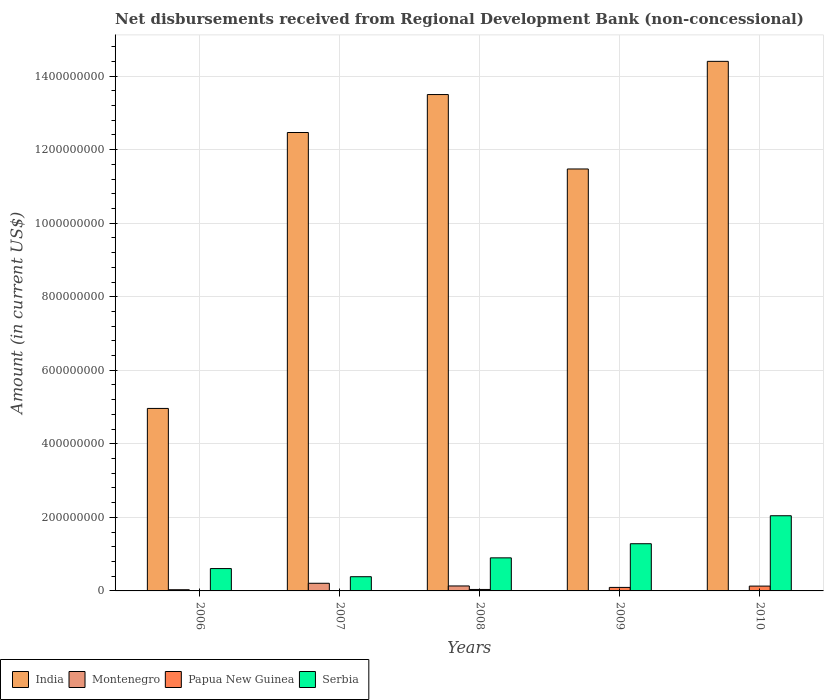How many different coloured bars are there?
Offer a terse response. 4. How many groups of bars are there?
Make the answer very short. 5. Are the number of bars per tick equal to the number of legend labels?
Your response must be concise. No. Are the number of bars on each tick of the X-axis equal?
Keep it short and to the point. No. How many bars are there on the 1st tick from the left?
Your answer should be compact. 3. How many bars are there on the 4th tick from the right?
Keep it short and to the point. 3. What is the amount of disbursements received from Regional Development Bank in Serbia in 2010?
Ensure brevity in your answer.  2.04e+08. Across all years, what is the maximum amount of disbursements received from Regional Development Bank in Serbia?
Your answer should be compact. 2.04e+08. Across all years, what is the minimum amount of disbursements received from Regional Development Bank in Serbia?
Provide a succinct answer. 3.87e+07. In which year was the amount of disbursements received from Regional Development Bank in Serbia maximum?
Make the answer very short. 2010. What is the total amount of disbursements received from Regional Development Bank in Serbia in the graph?
Your answer should be compact. 5.22e+08. What is the difference between the amount of disbursements received from Regional Development Bank in Serbia in 2006 and that in 2007?
Your response must be concise. 2.21e+07. What is the difference between the amount of disbursements received from Regional Development Bank in Montenegro in 2007 and the amount of disbursements received from Regional Development Bank in Papua New Guinea in 2009?
Your response must be concise. 1.13e+07. What is the average amount of disbursements received from Regional Development Bank in Montenegro per year?
Give a very brief answer. 7.71e+06. In the year 2006, what is the difference between the amount of disbursements received from Regional Development Bank in Montenegro and amount of disbursements received from Regional Development Bank in Serbia?
Keep it short and to the point. -5.75e+07. What is the ratio of the amount of disbursements received from Regional Development Bank in India in 2008 to that in 2009?
Ensure brevity in your answer.  1.18. Is the amount of disbursements received from Regional Development Bank in India in 2009 less than that in 2010?
Provide a short and direct response. Yes. Is the difference between the amount of disbursements received from Regional Development Bank in Montenegro in 2006 and 2007 greater than the difference between the amount of disbursements received from Regional Development Bank in Serbia in 2006 and 2007?
Give a very brief answer. No. What is the difference between the highest and the second highest amount of disbursements received from Regional Development Bank in Papua New Guinea?
Keep it short and to the point. 3.55e+06. What is the difference between the highest and the lowest amount of disbursements received from Regional Development Bank in India?
Give a very brief answer. 9.44e+08. Is it the case that in every year, the sum of the amount of disbursements received from Regional Development Bank in Papua New Guinea and amount of disbursements received from Regional Development Bank in Serbia is greater than the sum of amount of disbursements received from Regional Development Bank in Montenegro and amount of disbursements received from Regional Development Bank in India?
Offer a very short reply. No. Is it the case that in every year, the sum of the amount of disbursements received from Regional Development Bank in India and amount of disbursements received from Regional Development Bank in Serbia is greater than the amount of disbursements received from Regional Development Bank in Papua New Guinea?
Your answer should be very brief. Yes. Are all the bars in the graph horizontal?
Provide a succinct answer. No. How many years are there in the graph?
Your response must be concise. 5. Are the values on the major ticks of Y-axis written in scientific E-notation?
Your answer should be compact. No. Does the graph contain any zero values?
Your answer should be very brief. Yes. Where does the legend appear in the graph?
Your response must be concise. Bottom left. How are the legend labels stacked?
Ensure brevity in your answer.  Horizontal. What is the title of the graph?
Offer a terse response. Net disbursements received from Regional Development Bank (non-concessional). Does "Papua New Guinea" appear as one of the legend labels in the graph?
Offer a terse response. Yes. What is the label or title of the Y-axis?
Your answer should be very brief. Amount (in current US$). What is the Amount (in current US$) of India in 2006?
Keep it short and to the point. 4.96e+08. What is the Amount (in current US$) in Montenegro in 2006?
Make the answer very short. 3.25e+06. What is the Amount (in current US$) of Serbia in 2006?
Provide a short and direct response. 6.08e+07. What is the Amount (in current US$) in India in 2007?
Give a very brief answer. 1.25e+09. What is the Amount (in current US$) in Montenegro in 2007?
Offer a very short reply. 2.08e+07. What is the Amount (in current US$) of Serbia in 2007?
Make the answer very short. 3.87e+07. What is the Amount (in current US$) in India in 2008?
Keep it short and to the point. 1.35e+09. What is the Amount (in current US$) of Montenegro in 2008?
Your response must be concise. 1.35e+07. What is the Amount (in current US$) in Papua New Guinea in 2008?
Offer a terse response. 3.96e+06. What is the Amount (in current US$) in Serbia in 2008?
Ensure brevity in your answer.  8.99e+07. What is the Amount (in current US$) in India in 2009?
Make the answer very short. 1.15e+09. What is the Amount (in current US$) of Montenegro in 2009?
Offer a very short reply. 1.02e+06. What is the Amount (in current US$) of Papua New Guinea in 2009?
Your response must be concise. 9.55e+06. What is the Amount (in current US$) in Serbia in 2009?
Your response must be concise. 1.28e+08. What is the Amount (in current US$) of India in 2010?
Make the answer very short. 1.44e+09. What is the Amount (in current US$) of Papua New Guinea in 2010?
Offer a very short reply. 1.31e+07. What is the Amount (in current US$) in Serbia in 2010?
Give a very brief answer. 2.04e+08. Across all years, what is the maximum Amount (in current US$) in India?
Your answer should be very brief. 1.44e+09. Across all years, what is the maximum Amount (in current US$) in Montenegro?
Provide a short and direct response. 2.08e+07. Across all years, what is the maximum Amount (in current US$) in Papua New Guinea?
Keep it short and to the point. 1.31e+07. Across all years, what is the maximum Amount (in current US$) in Serbia?
Give a very brief answer. 2.04e+08. Across all years, what is the minimum Amount (in current US$) in India?
Provide a short and direct response. 4.96e+08. Across all years, what is the minimum Amount (in current US$) of Papua New Guinea?
Give a very brief answer. 0. Across all years, what is the minimum Amount (in current US$) of Serbia?
Your answer should be very brief. 3.87e+07. What is the total Amount (in current US$) of India in the graph?
Ensure brevity in your answer.  5.68e+09. What is the total Amount (in current US$) in Montenegro in the graph?
Your answer should be very brief. 3.86e+07. What is the total Amount (in current US$) in Papua New Guinea in the graph?
Offer a terse response. 2.66e+07. What is the total Amount (in current US$) in Serbia in the graph?
Offer a very short reply. 5.22e+08. What is the difference between the Amount (in current US$) of India in 2006 and that in 2007?
Your answer should be very brief. -7.50e+08. What is the difference between the Amount (in current US$) in Montenegro in 2006 and that in 2007?
Your answer should be compact. -1.76e+07. What is the difference between the Amount (in current US$) of Serbia in 2006 and that in 2007?
Provide a succinct answer. 2.21e+07. What is the difference between the Amount (in current US$) in India in 2006 and that in 2008?
Provide a short and direct response. -8.54e+08. What is the difference between the Amount (in current US$) of Montenegro in 2006 and that in 2008?
Your response must be concise. -1.02e+07. What is the difference between the Amount (in current US$) in Serbia in 2006 and that in 2008?
Give a very brief answer. -2.92e+07. What is the difference between the Amount (in current US$) in India in 2006 and that in 2009?
Ensure brevity in your answer.  -6.51e+08. What is the difference between the Amount (in current US$) in Montenegro in 2006 and that in 2009?
Offer a terse response. 2.23e+06. What is the difference between the Amount (in current US$) in Serbia in 2006 and that in 2009?
Offer a very short reply. -6.76e+07. What is the difference between the Amount (in current US$) in India in 2006 and that in 2010?
Offer a very short reply. -9.44e+08. What is the difference between the Amount (in current US$) in Serbia in 2006 and that in 2010?
Your answer should be very brief. -1.44e+08. What is the difference between the Amount (in current US$) of India in 2007 and that in 2008?
Provide a succinct answer. -1.03e+08. What is the difference between the Amount (in current US$) of Montenegro in 2007 and that in 2008?
Your answer should be very brief. 7.33e+06. What is the difference between the Amount (in current US$) of Serbia in 2007 and that in 2008?
Offer a terse response. -5.13e+07. What is the difference between the Amount (in current US$) in India in 2007 and that in 2009?
Your answer should be very brief. 9.92e+07. What is the difference between the Amount (in current US$) of Montenegro in 2007 and that in 2009?
Provide a succinct answer. 1.98e+07. What is the difference between the Amount (in current US$) in Serbia in 2007 and that in 2009?
Your answer should be compact. -8.97e+07. What is the difference between the Amount (in current US$) in India in 2007 and that in 2010?
Keep it short and to the point. -1.93e+08. What is the difference between the Amount (in current US$) of Serbia in 2007 and that in 2010?
Provide a succinct answer. -1.66e+08. What is the difference between the Amount (in current US$) of India in 2008 and that in 2009?
Ensure brevity in your answer.  2.02e+08. What is the difference between the Amount (in current US$) in Montenegro in 2008 and that in 2009?
Provide a short and direct response. 1.25e+07. What is the difference between the Amount (in current US$) of Papua New Guinea in 2008 and that in 2009?
Give a very brief answer. -5.58e+06. What is the difference between the Amount (in current US$) in Serbia in 2008 and that in 2009?
Provide a short and direct response. -3.84e+07. What is the difference between the Amount (in current US$) of India in 2008 and that in 2010?
Ensure brevity in your answer.  -9.03e+07. What is the difference between the Amount (in current US$) of Papua New Guinea in 2008 and that in 2010?
Provide a short and direct response. -9.13e+06. What is the difference between the Amount (in current US$) in Serbia in 2008 and that in 2010?
Provide a succinct answer. -1.15e+08. What is the difference between the Amount (in current US$) in India in 2009 and that in 2010?
Make the answer very short. -2.93e+08. What is the difference between the Amount (in current US$) of Papua New Guinea in 2009 and that in 2010?
Keep it short and to the point. -3.55e+06. What is the difference between the Amount (in current US$) in Serbia in 2009 and that in 2010?
Your response must be concise. -7.61e+07. What is the difference between the Amount (in current US$) of India in 2006 and the Amount (in current US$) of Montenegro in 2007?
Make the answer very short. 4.75e+08. What is the difference between the Amount (in current US$) in India in 2006 and the Amount (in current US$) in Serbia in 2007?
Provide a succinct answer. 4.58e+08. What is the difference between the Amount (in current US$) of Montenegro in 2006 and the Amount (in current US$) of Serbia in 2007?
Offer a very short reply. -3.54e+07. What is the difference between the Amount (in current US$) of India in 2006 and the Amount (in current US$) of Montenegro in 2008?
Provide a short and direct response. 4.83e+08. What is the difference between the Amount (in current US$) in India in 2006 and the Amount (in current US$) in Papua New Guinea in 2008?
Keep it short and to the point. 4.92e+08. What is the difference between the Amount (in current US$) of India in 2006 and the Amount (in current US$) of Serbia in 2008?
Your answer should be very brief. 4.06e+08. What is the difference between the Amount (in current US$) of Montenegro in 2006 and the Amount (in current US$) of Papua New Guinea in 2008?
Your response must be concise. -7.18e+05. What is the difference between the Amount (in current US$) in Montenegro in 2006 and the Amount (in current US$) in Serbia in 2008?
Offer a terse response. -8.67e+07. What is the difference between the Amount (in current US$) in India in 2006 and the Amount (in current US$) in Montenegro in 2009?
Make the answer very short. 4.95e+08. What is the difference between the Amount (in current US$) in India in 2006 and the Amount (in current US$) in Papua New Guinea in 2009?
Your answer should be compact. 4.87e+08. What is the difference between the Amount (in current US$) in India in 2006 and the Amount (in current US$) in Serbia in 2009?
Give a very brief answer. 3.68e+08. What is the difference between the Amount (in current US$) of Montenegro in 2006 and the Amount (in current US$) of Papua New Guinea in 2009?
Your answer should be very brief. -6.30e+06. What is the difference between the Amount (in current US$) of Montenegro in 2006 and the Amount (in current US$) of Serbia in 2009?
Ensure brevity in your answer.  -1.25e+08. What is the difference between the Amount (in current US$) of India in 2006 and the Amount (in current US$) of Papua New Guinea in 2010?
Make the answer very short. 4.83e+08. What is the difference between the Amount (in current US$) of India in 2006 and the Amount (in current US$) of Serbia in 2010?
Give a very brief answer. 2.92e+08. What is the difference between the Amount (in current US$) of Montenegro in 2006 and the Amount (in current US$) of Papua New Guinea in 2010?
Your answer should be compact. -9.85e+06. What is the difference between the Amount (in current US$) of Montenegro in 2006 and the Amount (in current US$) of Serbia in 2010?
Offer a very short reply. -2.01e+08. What is the difference between the Amount (in current US$) in India in 2007 and the Amount (in current US$) in Montenegro in 2008?
Offer a terse response. 1.23e+09. What is the difference between the Amount (in current US$) in India in 2007 and the Amount (in current US$) in Papua New Guinea in 2008?
Ensure brevity in your answer.  1.24e+09. What is the difference between the Amount (in current US$) in India in 2007 and the Amount (in current US$) in Serbia in 2008?
Provide a succinct answer. 1.16e+09. What is the difference between the Amount (in current US$) of Montenegro in 2007 and the Amount (in current US$) of Papua New Guinea in 2008?
Your response must be concise. 1.69e+07. What is the difference between the Amount (in current US$) in Montenegro in 2007 and the Amount (in current US$) in Serbia in 2008?
Provide a succinct answer. -6.91e+07. What is the difference between the Amount (in current US$) of India in 2007 and the Amount (in current US$) of Montenegro in 2009?
Keep it short and to the point. 1.25e+09. What is the difference between the Amount (in current US$) in India in 2007 and the Amount (in current US$) in Papua New Guinea in 2009?
Ensure brevity in your answer.  1.24e+09. What is the difference between the Amount (in current US$) of India in 2007 and the Amount (in current US$) of Serbia in 2009?
Offer a very short reply. 1.12e+09. What is the difference between the Amount (in current US$) in Montenegro in 2007 and the Amount (in current US$) in Papua New Guinea in 2009?
Ensure brevity in your answer.  1.13e+07. What is the difference between the Amount (in current US$) in Montenegro in 2007 and the Amount (in current US$) in Serbia in 2009?
Your response must be concise. -1.08e+08. What is the difference between the Amount (in current US$) in India in 2007 and the Amount (in current US$) in Papua New Guinea in 2010?
Offer a terse response. 1.23e+09. What is the difference between the Amount (in current US$) in India in 2007 and the Amount (in current US$) in Serbia in 2010?
Ensure brevity in your answer.  1.04e+09. What is the difference between the Amount (in current US$) of Montenegro in 2007 and the Amount (in current US$) of Papua New Guinea in 2010?
Offer a terse response. 7.72e+06. What is the difference between the Amount (in current US$) in Montenegro in 2007 and the Amount (in current US$) in Serbia in 2010?
Offer a terse response. -1.84e+08. What is the difference between the Amount (in current US$) of India in 2008 and the Amount (in current US$) of Montenegro in 2009?
Provide a succinct answer. 1.35e+09. What is the difference between the Amount (in current US$) of India in 2008 and the Amount (in current US$) of Papua New Guinea in 2009?
Offer a terse response. 1.34e+09. What is the difference between the Amount (in current US$) in India in 2008 and the Amount (in current US$) in Serbia in 2009?
Provide a short and direct response. 1.22e+09. What is the difference between the Amount (in current US$) of Montenegro in 2008 and the Amount (in current US$) of Papua New Guinea in 2009?
Provide a succinct answer. 3.94e+06. What is the difference between the Amount (in current US$) of Montenegro in 2008 and the Amount (in current US$) of Serbia in 2009?
Keep it short and to the point. -1.15e+08. What is the difference between the Amount (in current US$) in Papua New Guinea in 2008 and the Amount (in current US$) in Serbia in 2009?
Make the answer very short. -1.24e+08. What is the difference between the Amount (in current US$) of India in 2008 and the Amount (in current US$) of Papua New Guinea in 2010?
Make the answer very short. 1.34e+09. What is the difference between the Amount (in current US$) of India in 2008 and the Amount (in current US$) of Serbia in 2010?
Keep it short and to the point. 1.15e+09. What is the difference between the Amount (in current US$) of Montenegro in 2008 and the Amount (in current US$) of Papua New Guinea in 2010?
Your response must be concise. 3.95e+05. What is the difference between the Amount (in current US$) of Montenegro in 2008 and the Amount (in current US$) of Serbia in 2010?
Your response must be concise. -1.91e+08. What is the difference between the Amount (in current US$) in Papua New Guinea in 2008 and the Amount (in current US$) in Serbia in 2010?
Give a very brief answer. -2.00e+08. What is the difference between the Amount (in current US$) of India in 2009 and the Amount (in current US$) of Papua New Guinea in 2010?
Offer a terse response. 1.13e+09. What is the difference between the Amount (in current US$) in India in 2009 and the Amount (in current US$) in Serbia in 2010?
Make the answer very short. 9.43e+08. What is the difference between the Amount (in current US$) of Montenegro in 2009 and the Amount (in current US$) of Papua New Guinea in 2010?
Provide a succinct answer. -1.21e+07. What is the difference between the Amount (in current US$) in Montenegro in 2009 and the Amount (in current US$) in Serbia in 2010?
Your answer should be compact. -2.03e+08. What is the difference between the Amount (in current US$) of Papua New Guinea in 2009 and the Amount (in current US$) of Serbia in 2010?
Keep it short and to the point. -1.95e+08. What is the average Amount (in current US$) of India per year?
Make the answer very short. 1.14e+09. What is the average Amount (in current US$) in Montenegro per year?
Provide a succinct answer. 7.71e+06. What is the average Amount (in current US$) of Papua New Guinea per year?
Your answer should be very brief. 5.32e+06. What is the average Amount (in current US$) of Serbia per year?
Provide a succinct answer. 1.04e+08. In the year 2006, what is the difference between the Amount (in current US$) of India and Amount (in current US$) of Montenegro?
Your response must be concise. 4.93e+08. In the year 2006, what is the difference between the Amount (in current US$) in India and Amount (in current US$) in Serbia?
Keep it short and to the point. 4.36e+08. In the year 2006, what is the difference between the Amount (in current US$) of Montenegro and Amount (in current US$) of Serbia?
Your answer should be very brief. -5.75e+07. In the year 2007, what is the difference between the Amount (in current US$) of India and Amount (in current US$) of Montenegro?
Provide a succinct answer. 1.23e+09. In the year 2007, what is the difference between the Amount (in current US$) of India and Amount (in current US$) of Serbia?
Provide a succinct answer. 1.21e+09. In the year 2007, what is the difference between the Amount (in current US$) in Montenegro and Amount (in current US$) in Serbia?
Give a very brief answer. -1.78e+07. In the year 2008, what is the difference between the Amount (in current US$) in India and Amount (in current US$) in Montenegro?
Your response must be concise. 1.34e+09. In the year 2008, what is the difference between the Amount (in current US$) in India and Amount (in current US$) in Papua New Guinea?
Offer a terse response. 1.35e+09. In the year 2008, what is the difference between the Amount (in current US$) of India and Amount (in current US$) of Serbia?
Your answer should be very brief. 1.26e+09. In the year 2008, what is the difference between the Amount (in current US$) of Montenegro and Amount (in current US$) of Papua New Guinea?
Provide a short and direct response. 9.53e+06. In the year 2008, what is the difference between the Amount (in current US$) in Montenegro and Amount (in current US$) in Serbia?
Keep it short and to the point. -7.64e+07. In the year 2008, what is the difference between the Amount (in current US$) of Papua New Guinea and Amount (in current US$) of Serbia?
Your answer should be very brief. -8.60e+07. In the year 2009, what is the difference between the Amount (in current US$) of India and Amount (in current US$) of Montenegro?
Your response must be concise. 1.15e+09. In the year 2009, what is the difference between the Amount (in current US$) in India and Amount (in current US$) in Papua New Guinea?
Offer a terse response. 1.14e+09. In the year 2009, what is the difference between the Amount (in current US$) of India and Amount (in current US$) of Serbia?
Provide a succinct answer. 1.02e+09. In the year 2009, what is the difference between the Amount (in current US$) in Montenegro and Amount (in current US$) in Papua New Guinea?
Your response must be concise. -8.53e+06. In the year 2009, what is the difference between the Amount (in current US$) in Montenegro and Amount (in current US$) in Serbia?
Provide a succinct answer. -1.27e+08. In the year 2009, what is the difference between the Amount (in current US$) in Papua New Guinea and Amount (in current US$) in Serbia?
Your answer should be very brief. -1.19e+08. In the year 2010, what is the difference between the Amount (in current US$) in India and Amount (in current US$) in Papua New Guinea?
Keep it short and to the point. 1.43e+09. In the year 2010, what is the difference between the Amount (in current US$) in India and Amount (in current US$) in Serbia?
Offer a terse response. 1.24e+09. In the year 2010, what is the difference between the Amount (in current US$) in Papua New Guinea and Amount (in current US$) in Serbia?
Ensure brevity in your answer.  -1.91e+08. What is the ratio of the Amount (in current US$) in India in 2006 to that in 2007?
Offer a terse response. 0.4. What is the ratio of the Amount (in current US$) of Montenegro in 2006 to that in 2007?
Provide a short and direct response. 0.16. What is the ratio of the Amount (in current US$) in Serbia in 2006 to that in 2007?
Keep it short and to the point. 1.57. What is the ratio of the Amount (in current US$) in India in 2006 to that in 2008?
Provide a succinct answer. 0.37. What is the ratio of the Amount (in current US$) in Montenegro in 2006 to that in 2008?
Your answer should be compact. 0.24. What is the ratio of the Amount (in current US$) of Serbia in 2006 to that in 2008?
Make the answer very short. 0.68. What is the ratio of the Amount (in current US$) in India in 2006 to that in 2009?
Provide a short and direct response. 0.43. What is the ratio of the Amount (in current US$) of Montenegro in 2006 to that in 2009?
Make the answer very short. 3.19. What is the ratio of the Amount (in current US$) of Serbia in 2006 to that in 2009?
Keep it short and to the point. 0.47. What is the ratio of the Amount (in current US$) of India in 2006 to that in 2010?
Offer a terse response. 0.34. What is the ratio of the Amount (in current US$) of Serbia in 2006 to that in 2010?
Provide a succinct answer. 0.3. What is the ratio of the Amount (in current US$) in India in 2007 to that in 2008?
Provide a short and direct response. 0.92. What is the ratio of the Amount (in current US$) in Montenegro in 2007 to that in 2008?
Make the answer very short. 1.54. What is the ratio of the Amount (in current US$) of Serbia in 2007 to that in 2008?
Offer a terse response. 0.43. What is the ratio of the Amount (in current US$) in India in 2007 to that in 2009?
Provide a succinct answer. 1.09. What is the ratio of the Amount (in current US$) in Montenegro in 2007 to that in 2009?
Your answer should be compact. 20.49. What is the ratio of the Amount (in current US$) of Serbia in 2007 to that in 2009?
Offer a very short reply. 0.3. What is the ratio of the Amount (in current US$) of India in 2007 to that in 2010?
Your response must be concise. 0.87. What is the ratio of the Amount (in current US$) in Serbia in 2007 to that in 2010?
Offer a terse response. 0.19. What is the ratio of the Amount (in current US$) in India in 2008 to that in 2009?
Give a very brief answer. 1.18. What is the ratio of the Amount (in current US$) in Montenegro in 2008 to that in 2009?
Ensure brevity in your answer.  13.28. What is the ratio of the Amount (in current US$) in Papua New Guinea in 2008 to that in 2009?
Keep it short and to the point. 0.42. What is the ratio of the Amount (in current US$) in Serbia in 2008 to that in 2009?
Provide a short and direct response. 0.7. What is the ratio of the Amount (in current US$) of India in 2008 to that in 2010?
Offer a terse response. 0.94. What is the ratio of the Amount (in current US$) of Papua New Guinea in 2008 to that in 2010?
Provide a succinct answer. 0.3. What is the ratio of the Amount (in current US$) in Serbia in 2008 to that in 2010?
Your answer should be compact. 0.44. What is the ratio of the Amount (in current US$) of India in 2009 to that in 2010?
Offer a terse response. 0.8. What is the ratio of the Amount (in current US$) of Papua New Guinea in 2009 to that in 2010?
Your answer should be very brief. 0.73. What is the ratio of the Amount (in current US$) in Serbia in 2009 to that in 2010?
Ensure brevity in your answer.  0.63. What is the difference between the highest and the second highest Amount (in current US$) in India?
Ensure brevity in your answer.  9.03e+07. What is the difference between the highest and the second highest Amount (in current US$) in Montenegro?
Keep it short and to the point. 7.33e+06. What is the difference between the highest and the second highest Amount (in current US$) in Papua New Guinea?
Ensure brevity in your answer.  3.55e+06. What is the difference between the highest and the second highest Amount (in current US$) of Serbia?
Ensure brevity in your answer.  7.61e+07. What is the difference between the highest and the lowest Amount (in current US$) in India?
Provide a short and direct response. 9.44e+08. What is the difference between the highest and the lowest Amount (in current US$) of Montenegro?
Provide a short and direct response. 2.08e+07. What is the difference between the highest and the lowest Amount (in current US$) in Papua New Guinea?
Your response must be concise. 1.31e+07. What is the difference between the highest and the lowest Amount (in current US$) in Serbia?
Offer a very short reply. 1.66e+08. 